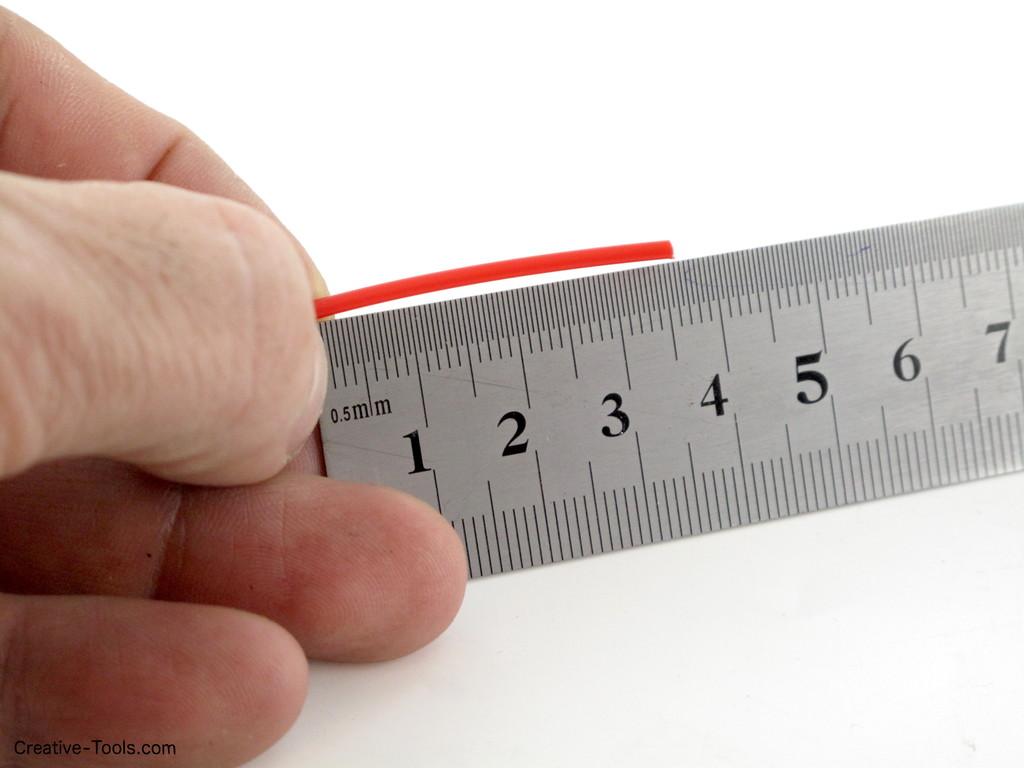How long is the piece of plastic?
Your answer should be very brief. 3.5. 